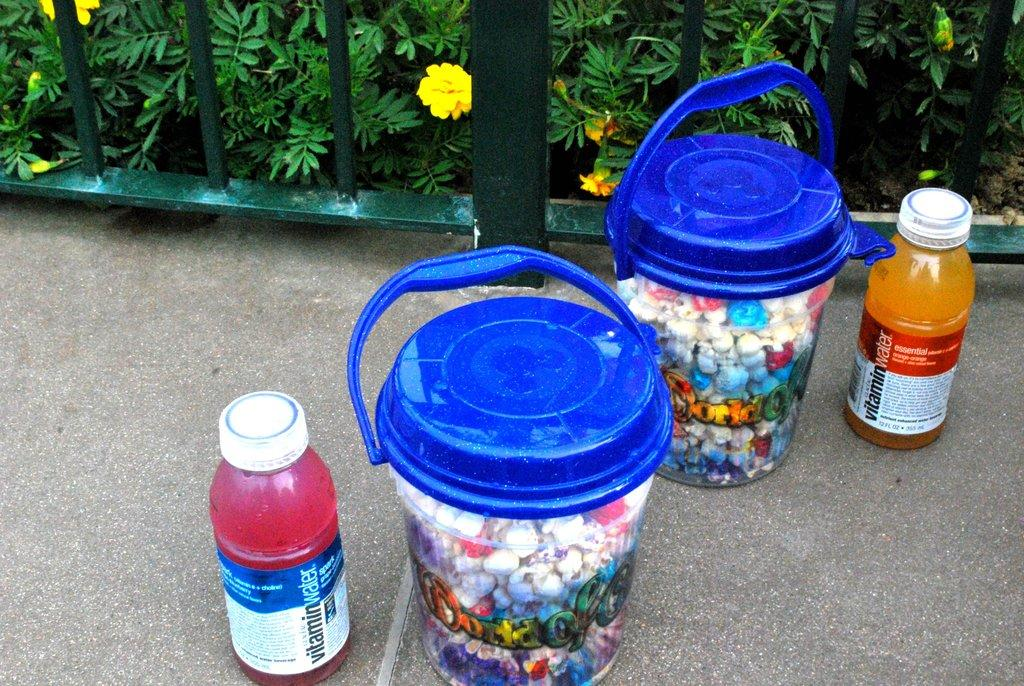<image>
Give a short and clear explanation of the subsequent image. Orange bottle of vitamin water next to a bucket. 